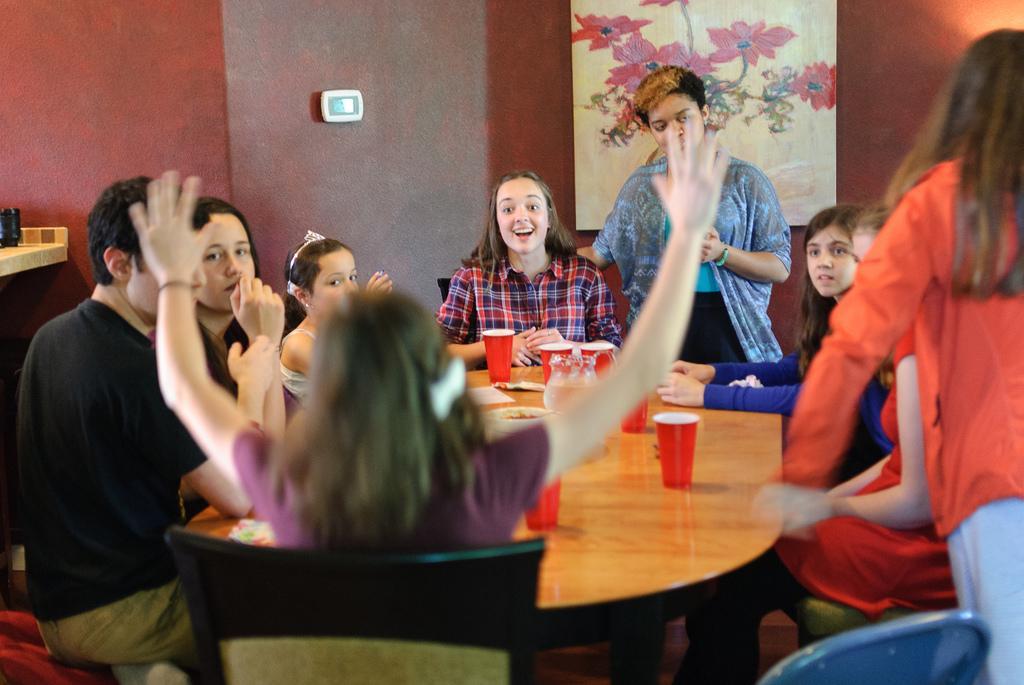How would you summarize this image in a sentence or two? This is a picture taken in a room, there are group of people performing the activities they are sitting on the chairs in front of this people there is a table on the table there are red cups background of the people there is a wall on the wall there is a painting. 